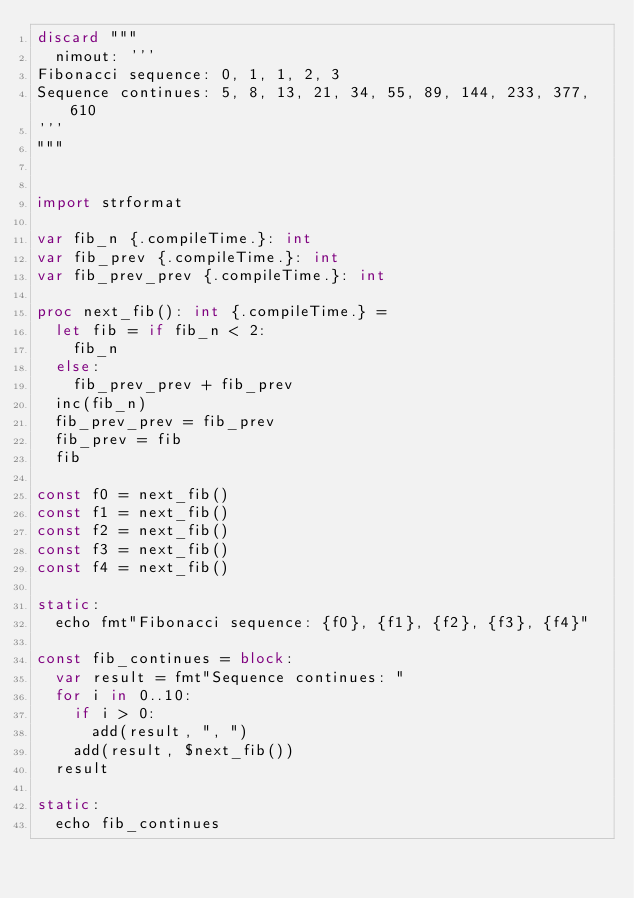<code> <loc_0><loc_0><loc_500><loc_500><_Nim_>discard """
  nimout: '''
Fibonacci sequence: 0, 1, 1, 2, 3
Sequence continues: 5, 8, 13, 21, 34, 55, 89, 144, 233, 377, 610
'''
"""


import strformat

var fib_n {.compileTime.}: int
var fib_prev {.compileTime.}: int
var fib_prev_prev {.compileTime.}: int

proc next_fib(): int {.compileTime.} =
  let fib = if fib_n < 2:
    fib_n
  else:
    fib_prev_prev + fib_prev
  inc(fib_n)
  fib_prev_prev = fib_prev
  fib_prev = fib
  fib

const f0 = next_fib()
const f1 = next_fib()
const f2 = next_fib()
const f3 = next_fib()
const f4 = next_fib()

static:
  echo fmt"Fibonacci sequence: {f0}, {f1}, {f2}, {f3}, {f4}"

const fib_continues = block:
  var result = fmt"Sequence continues: "
  for i in 0..10:
    if i > 0:
      add(result, ", ")
    add(result, $next_fib())
  result

static:
  echo fib_continues</code> 